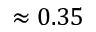<formula> <loc_0><loc_0><loc_500><loc_500>\approx 0 . 3 5</formula> 